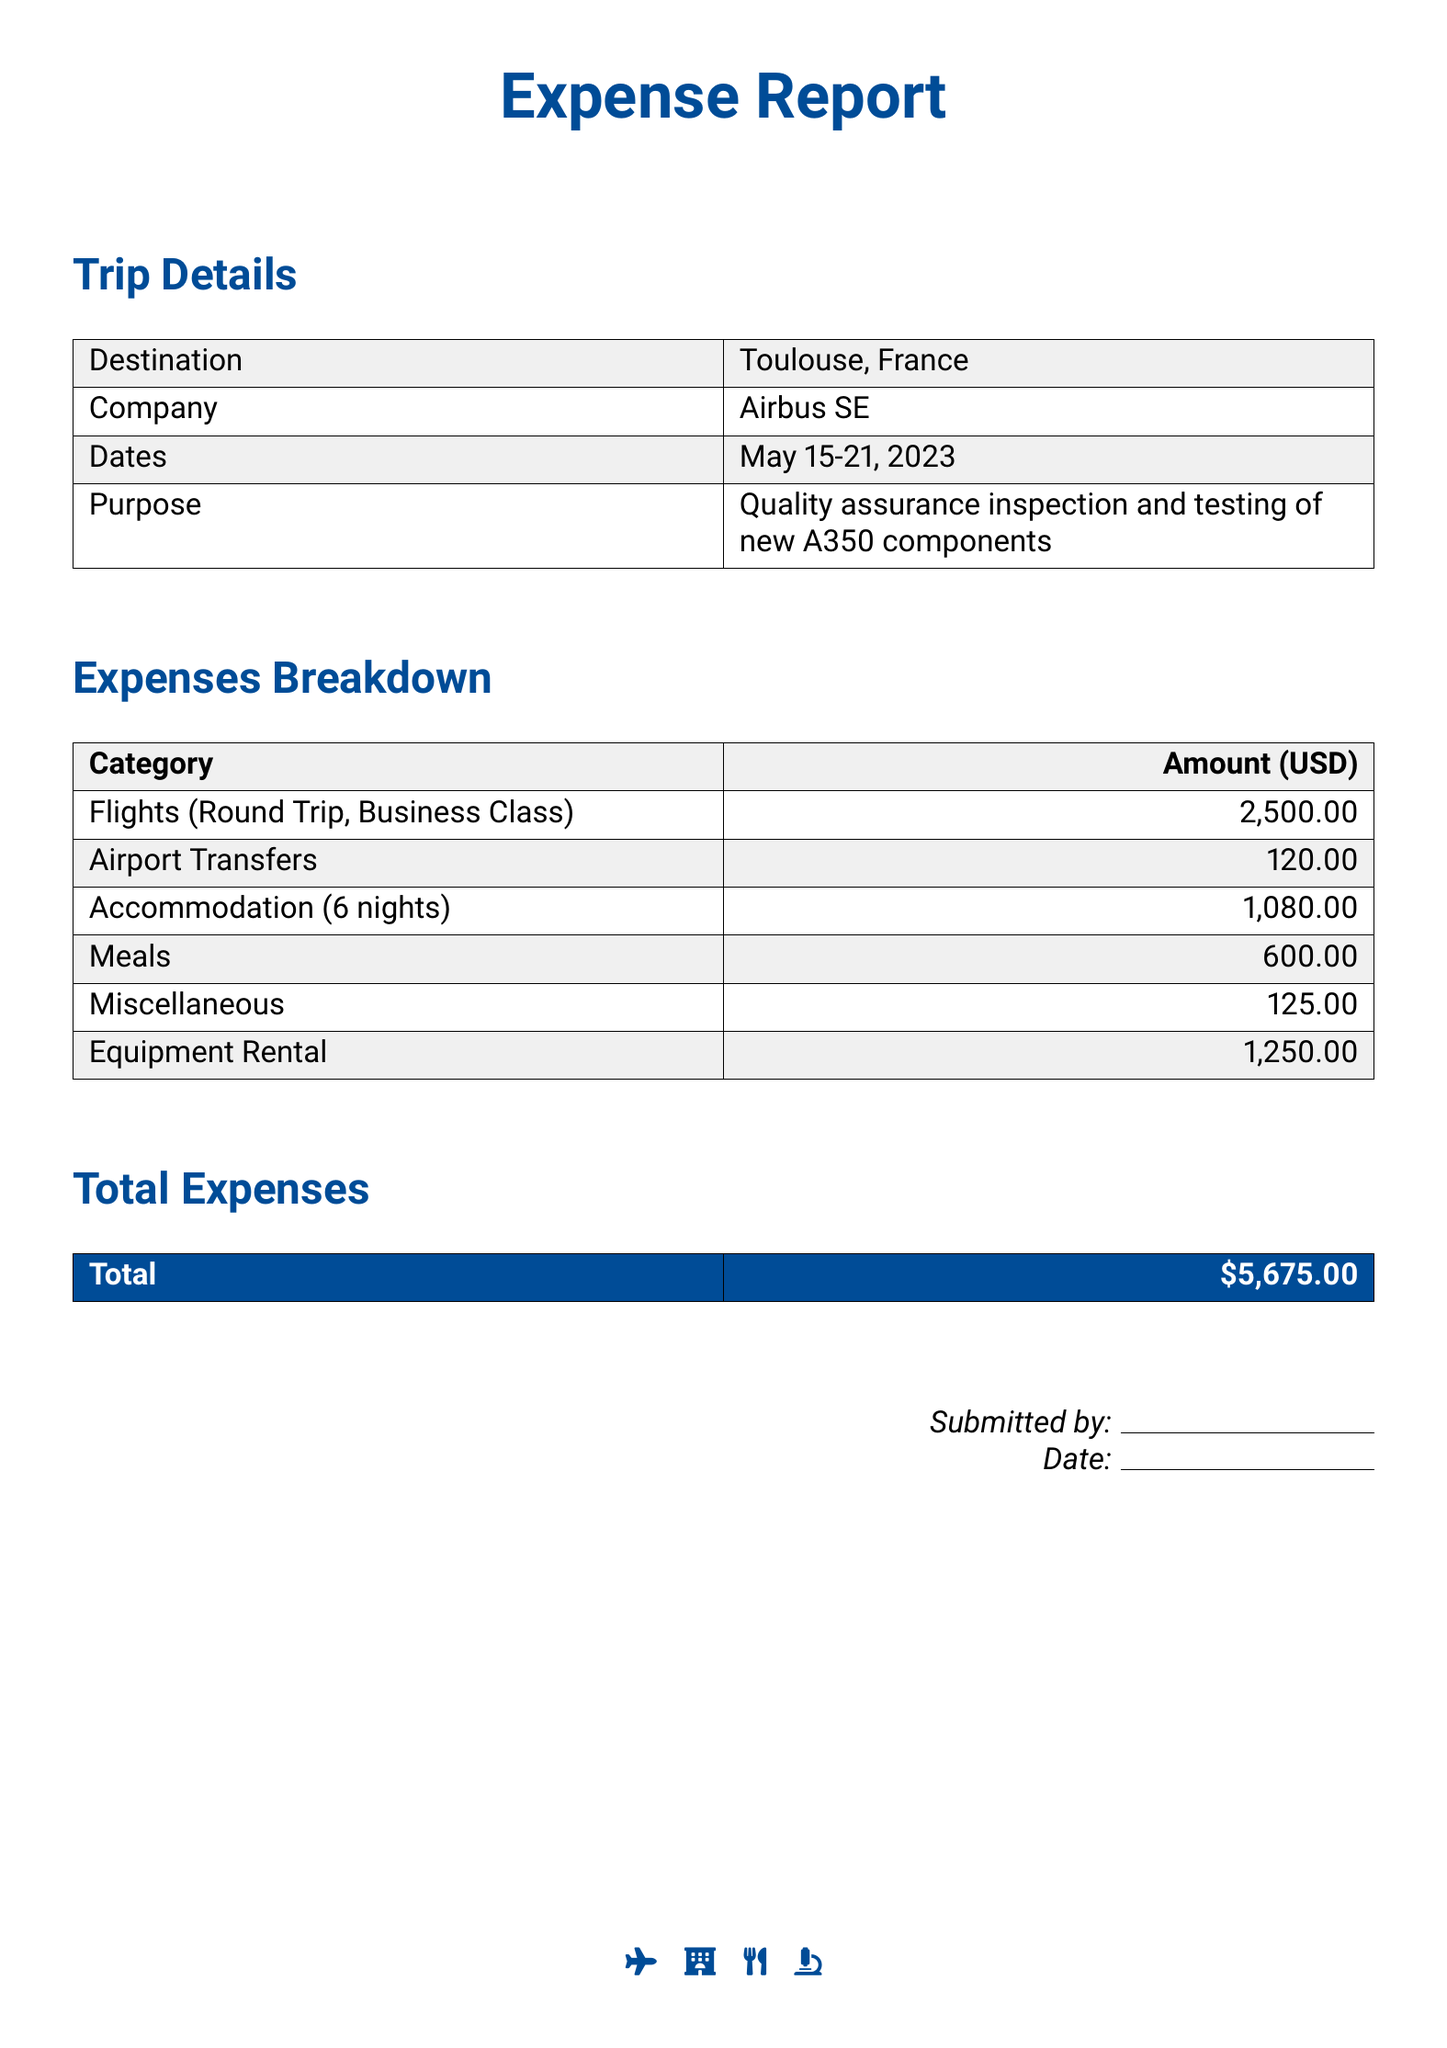What is the total amount of expenses? The total amount of expenses is clearly stated at the bottom of the document.
Answer: $5,675.00 What was the destination of the trip? The destination is specified in the trip details section of the document.
Answer: Toulouse, France How many nights of accommodation were booked? The number of nights is mentioned in the expenses breakdown section under accommodation.
Answer: 6 nights What was the cost for meals? The cost for meals is detailed in the expenses breakdown section.
Answer: $600.00 What is the purpose of the trip? The purpose is summarized in the trip details section of the document.
Answer: Quality assurance inspection and testing of new A350 components How much was spent on equipment rental? The document specifies the amount spent on equipment rental in the expenses breakdown section.
Answer: $1,250.00 What were the dates of the trip? The dates of the trip are listed in the trip details section of the document.
Answer: May 15-21, 2023 How much was spent on airport transfers? The amount for airport transfers can be found in the breakdown of expenses.
Answer: $120.00 What company was visited during the trip? The name of the company can be extracted from the trip details section.
Answer: Airbus SE 